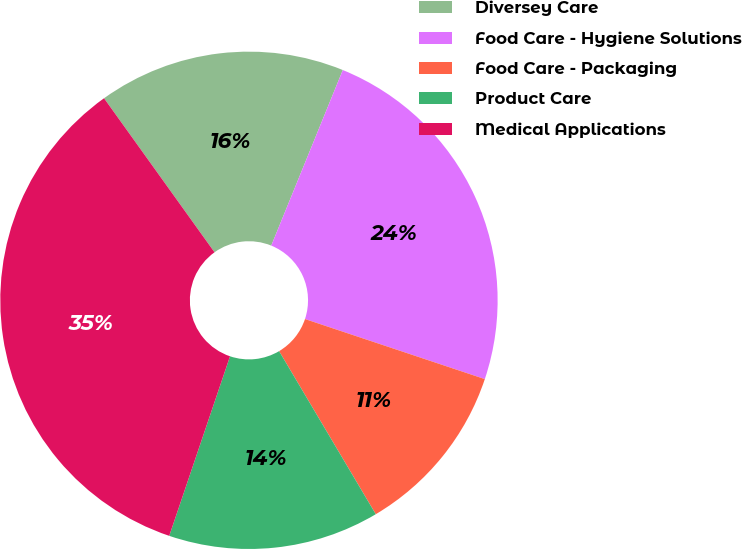<chart> <loc_0><loc_0><loc_500><loc_500><pie_chart><fcel>Diversey Care<fcel>Food Care - Hygiene Solutions<fcel>Food Care - Packaging<fcel>Product Care<fcel>Medical Applications<nl><fcel>16.06%<fcel>23.97%<fcel>11.35%<fcel>13.71%<fcel>34.9%<nl></chart> 